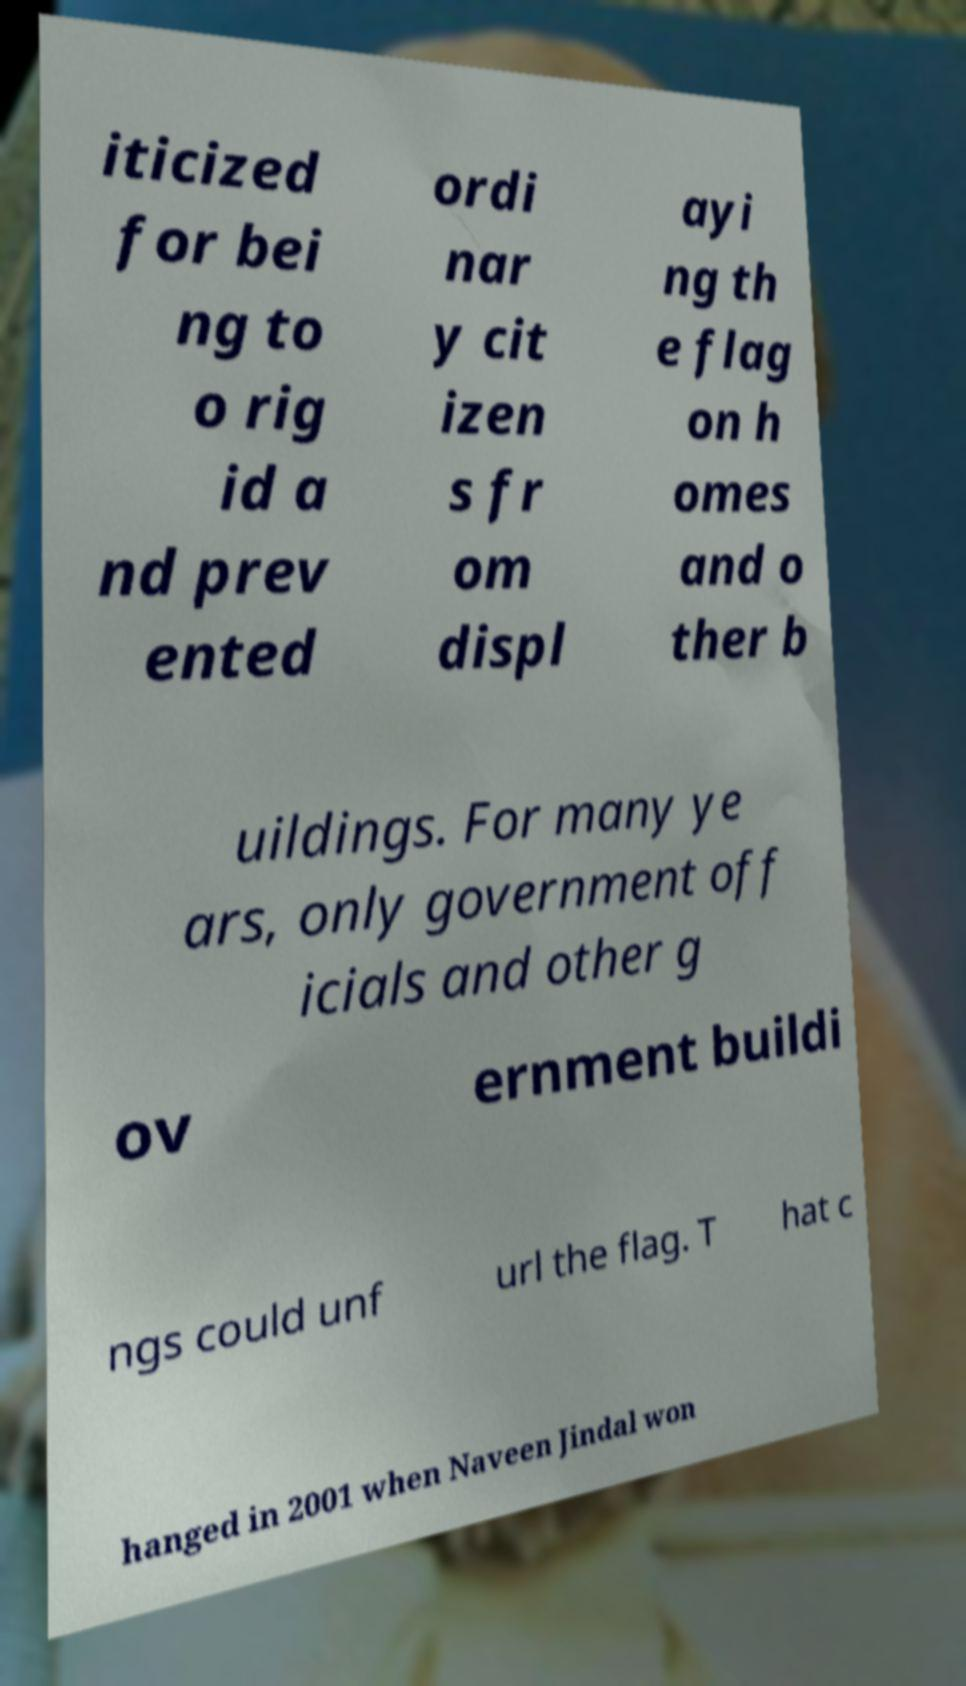Please read and relay the text visible in this image. What does it say? iticized for bei ng to o rig id a nd prev ented ordi nar y cit izen s fr om displ ayi ng th e flag on h omes and o ther b uildings. For many ye ars, only government off icials and other g ov ernment buildi ngs could unf url the flag. T hat c hanged in 2001 when Naveen Jindal won 